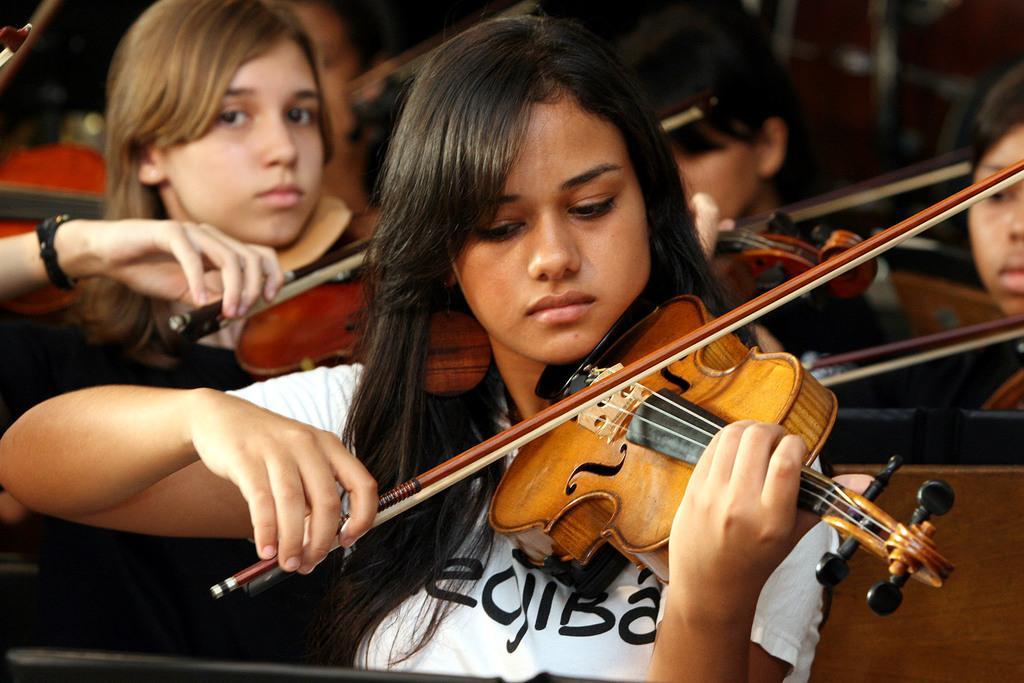Can you describe this image briefly? In this picture few people are playing violin. 